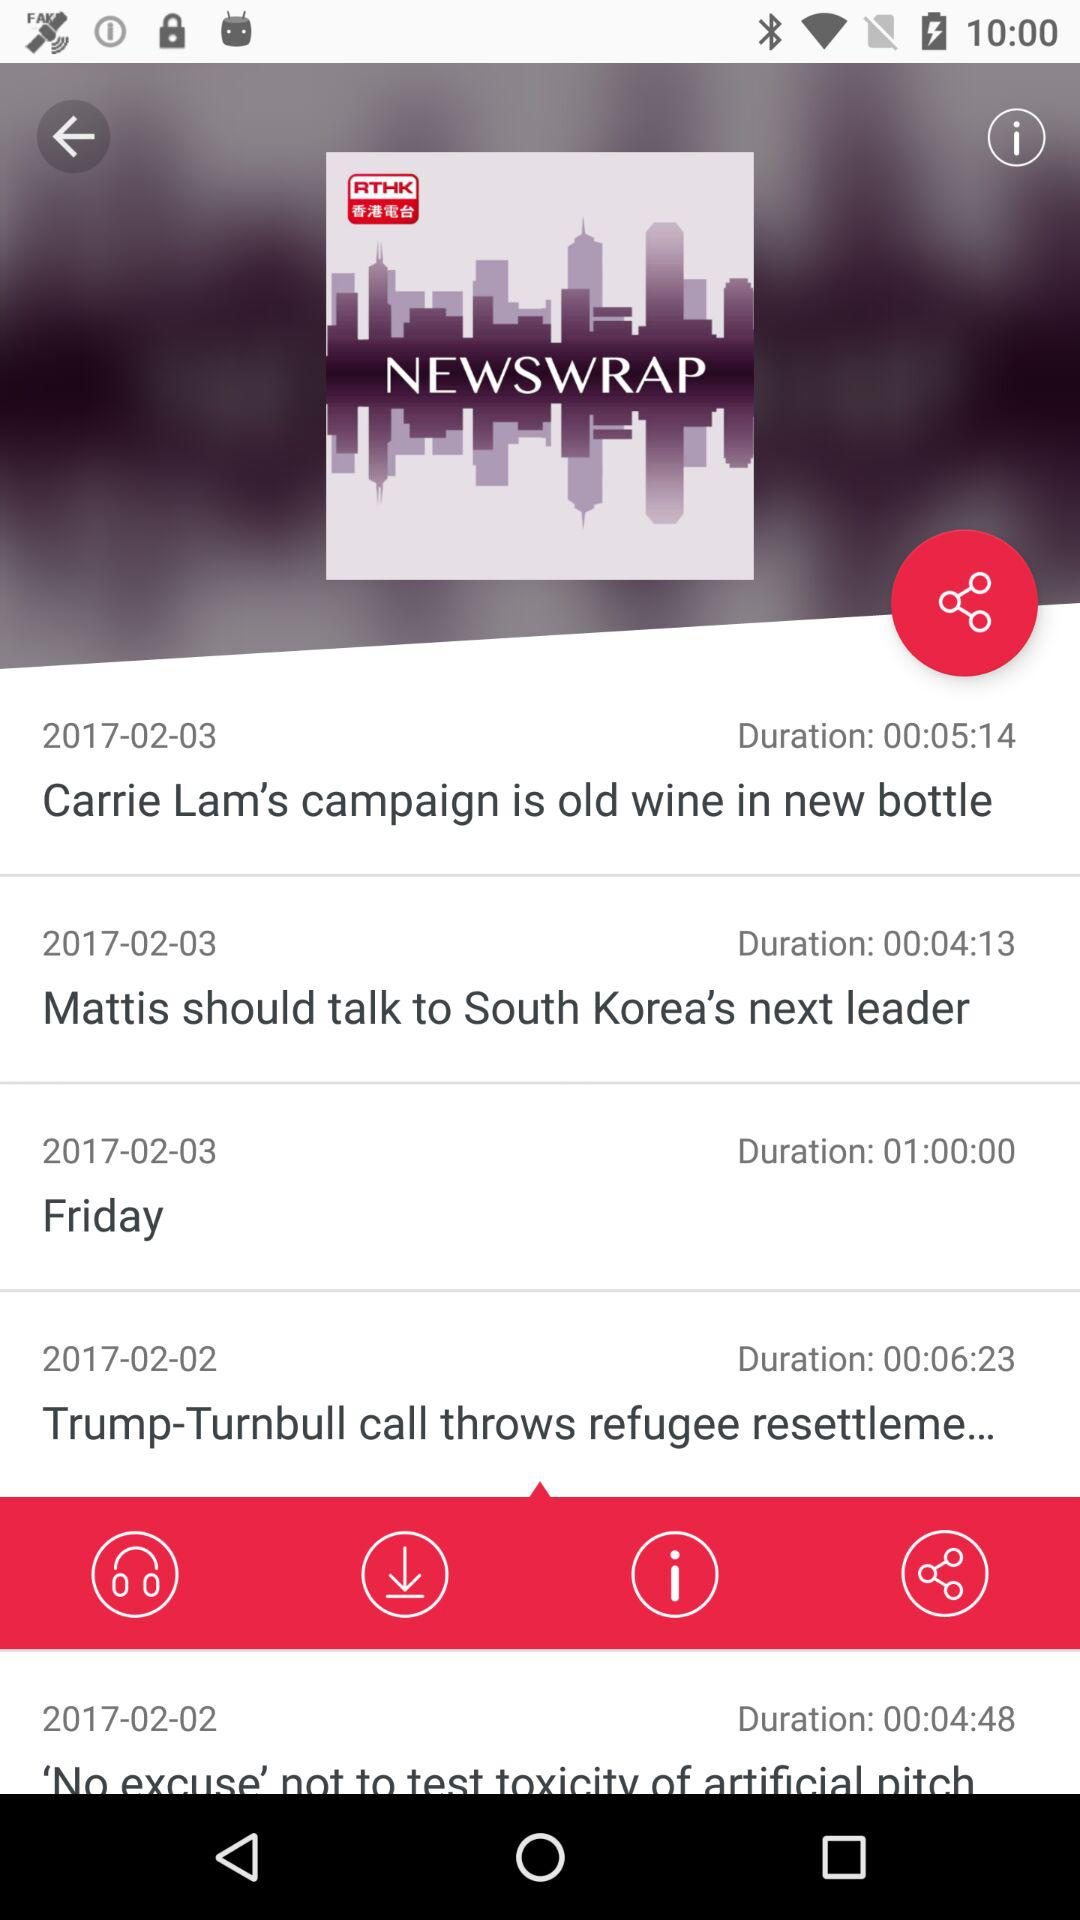What is the date for the news "Mattis should talk to South Korea's next leader"? The date is 2017-02-03. 